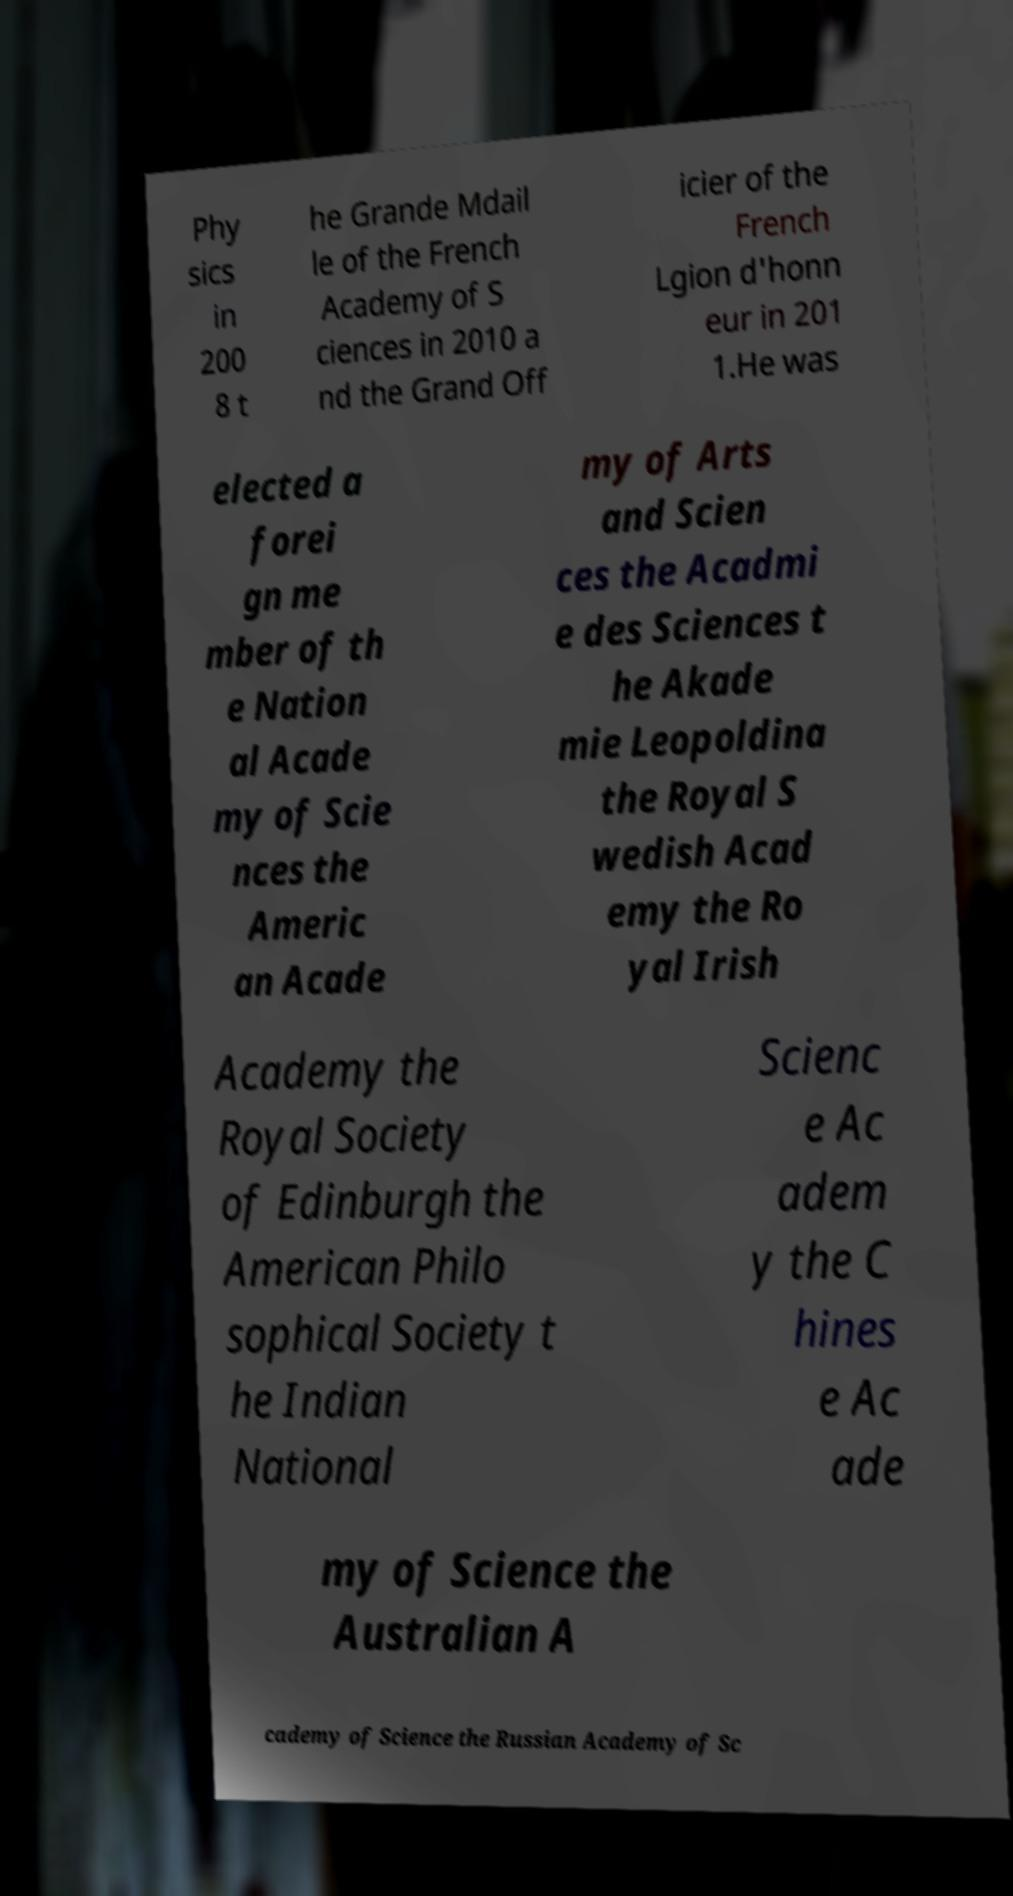Can you accurately transcribe the text from the provided image for me? Phy sics in 200 8 t he Grande Mdail le of the French Academy of S ciences in 2010 a nd the Grand Off icier of the French Lgion d'honn eur in 201 1.He was elected a forei gn me mber of th e Nation al Acade my of Scie nces the Americ an Acade my of Arts and Scien ces the Acadmi e des Sciences t he Akade mie Leopoldina the Royal S wedish Acad emy the Ro yal Irish Academy the Royal Society of Edinburgh the American Philo sophical Society t he Indian National Scienc e Ac adem y the C hines e Ac ade my of Science the Australian A cademy of Science the Russian Academy of Sc 